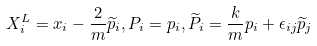<formula> <loc_0><loc_0><loc_500><loc_500>X _ { i } ^ { L } = x _ { i } - \frac { 2 } { m } \widetilde { p } _ { i } , P _ { i } = p _ { i } , \widetilde { P } _ { i } = \frac { k } { m } p _ { i } + \epsilon _ { i j } \widetilde { p } _ { j }</formula> 